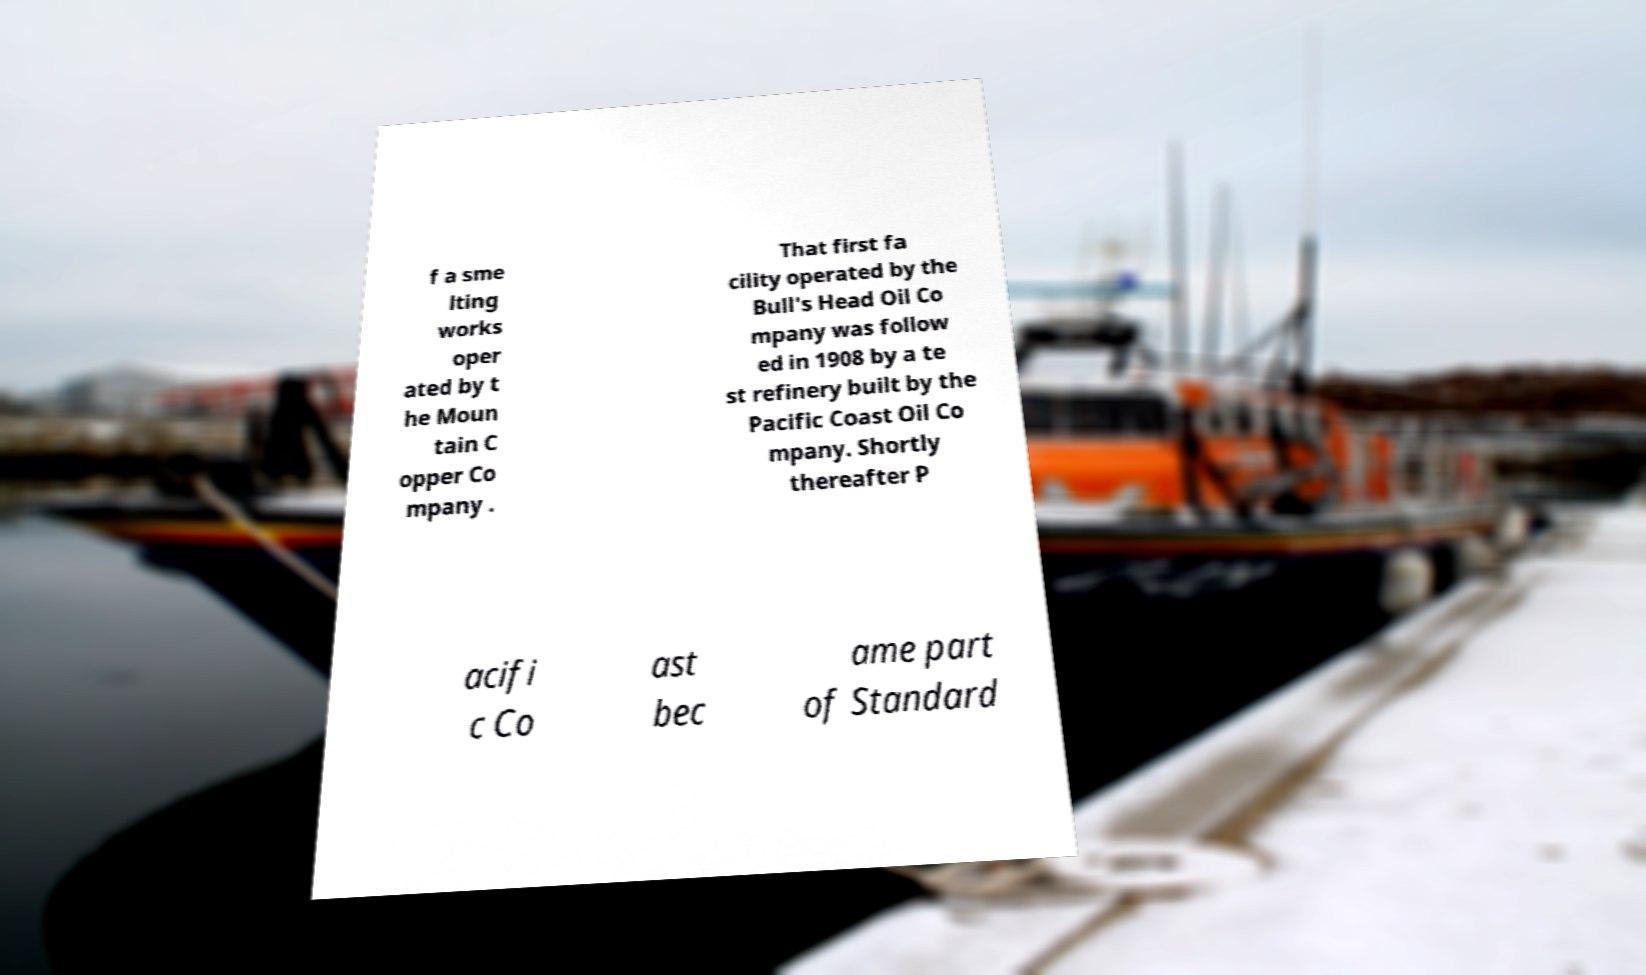There's text embedded in this image that I need extracted. Can you transcribe it verbatim? f a sme lting works oper ated by t he Moun tain C opper Co mpany . That first fa cility operated by the Bull's Head Oil Co mpany was follow ed in 1908 by a te st refinery built by the Pacific Coast Oil Co mpany. Shortly thereafter P acifi c Co ast bec ame part of Standard 